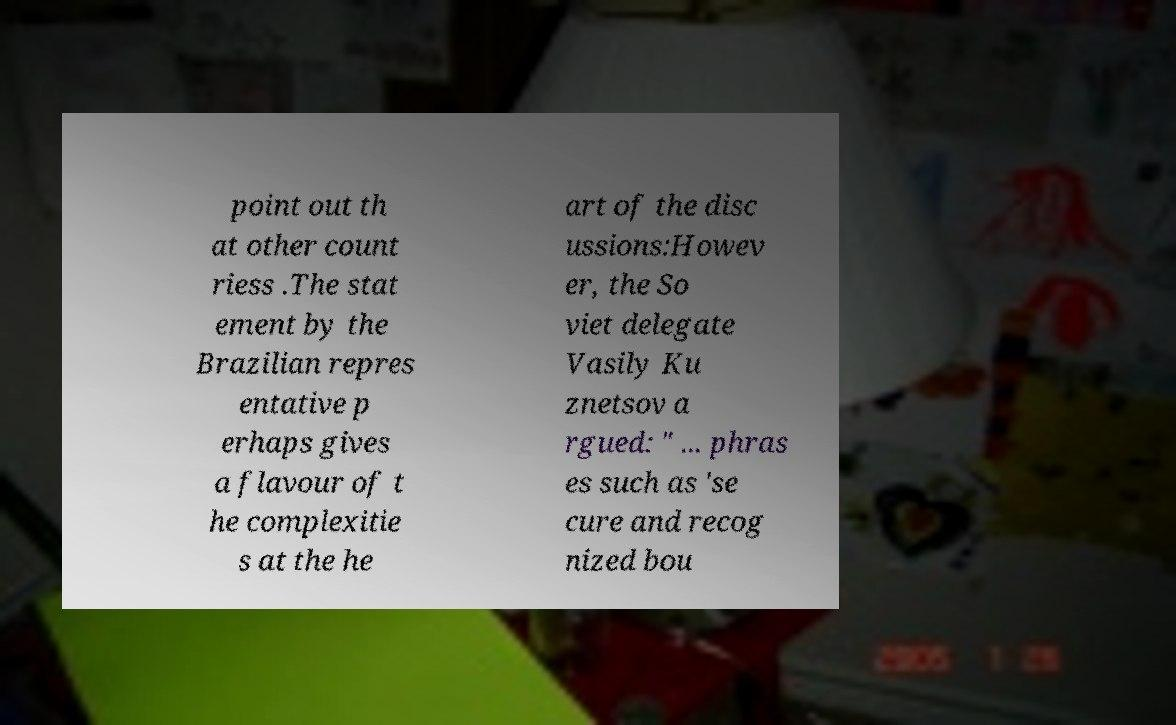Can you accurately transcribe the text from the provided image for me? point out th at other count riess .The stat ement by the Brazilian repres entative p erhaps gives a flavour of t he complexitie s at the he art of the disc ussions:Howev er, the So viet delegate Vasily Ku znetsov a rgued: " ... phras es such as 'se cure and recog nized bou 